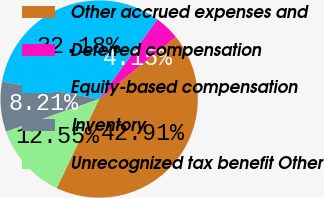Convert chart to OTSL. <chart><loc_0><loc_0><loc_500><loc_500><pie_chart><fcel>Other accrued expenses and<fcel>Deferred compensation<fcel>Equity-based compensation<fcel>Inventory<fcel>Unrecognized tax benefit Other<nl><fcel>42.91%<fcel>4.15%<fcel>32.18%<fcel>8.21%<fcel>12.55%<nl></chart> 